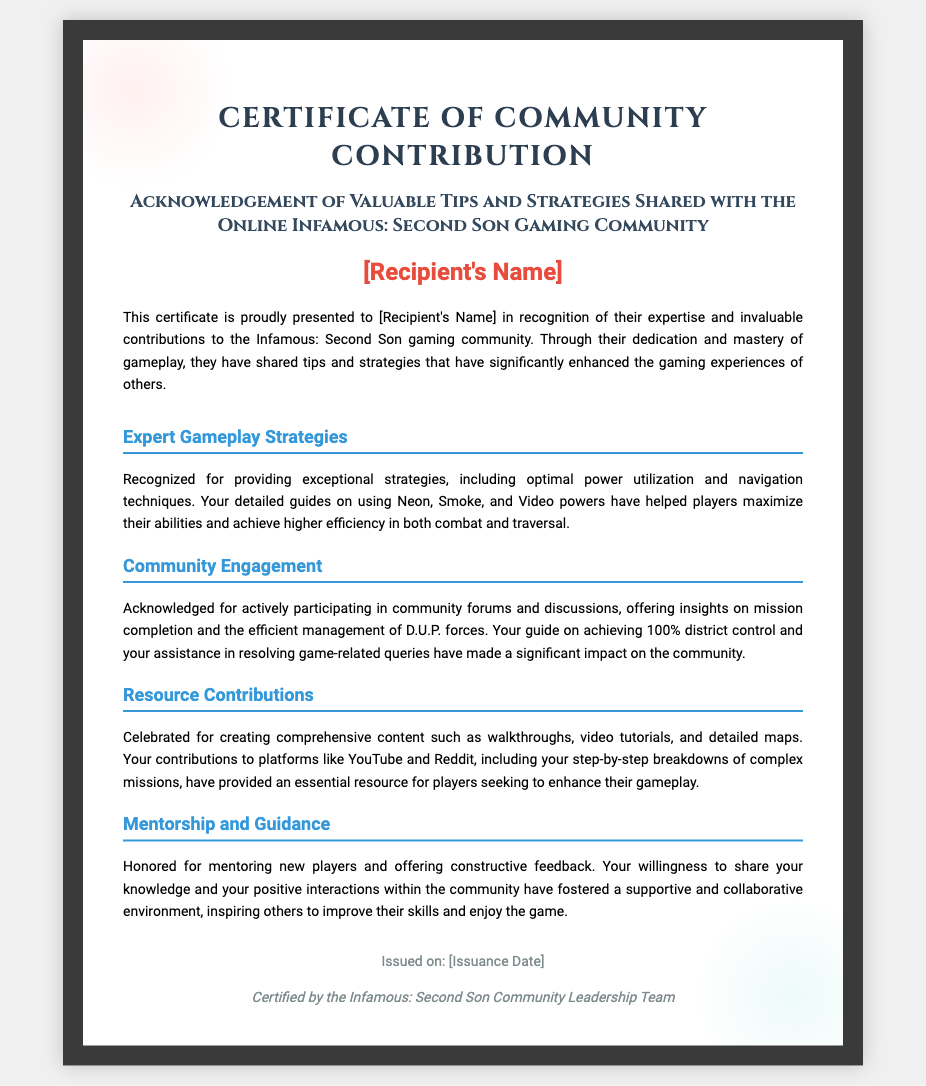What is the title of the document? The title is presented at the top of the certificate and indicates the purpose of the document.
Answer: Certificate of Community Contribution Who is the recipient of the certificate? The recipient's name is displayed prominently in the certificate, representing the person acknowledged.
Answer: [Recipient's Name] What is celebrated in the Resource Contributions section? The Resource Contributions section highlights specific contributions made by the recipient to assist other players.
Answer: Creating comprehensive content What does the Mentorship and Guidance section honor the recipient for? This section recognizes the impact of the recipient's interactions in helping others improve their gameplay skills.
Answer: Mentoring new players What date is mentioned in the footer of the document? The footer contains the issuance date, which signifies when the certificate was officially presented.
Answer: [Issuance Date] 